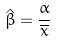<formula> <loc_0><loc_0><loc_500><loc_500>\hat { \beta } = \frac { \alpha } { \overline { x } }</formula> 